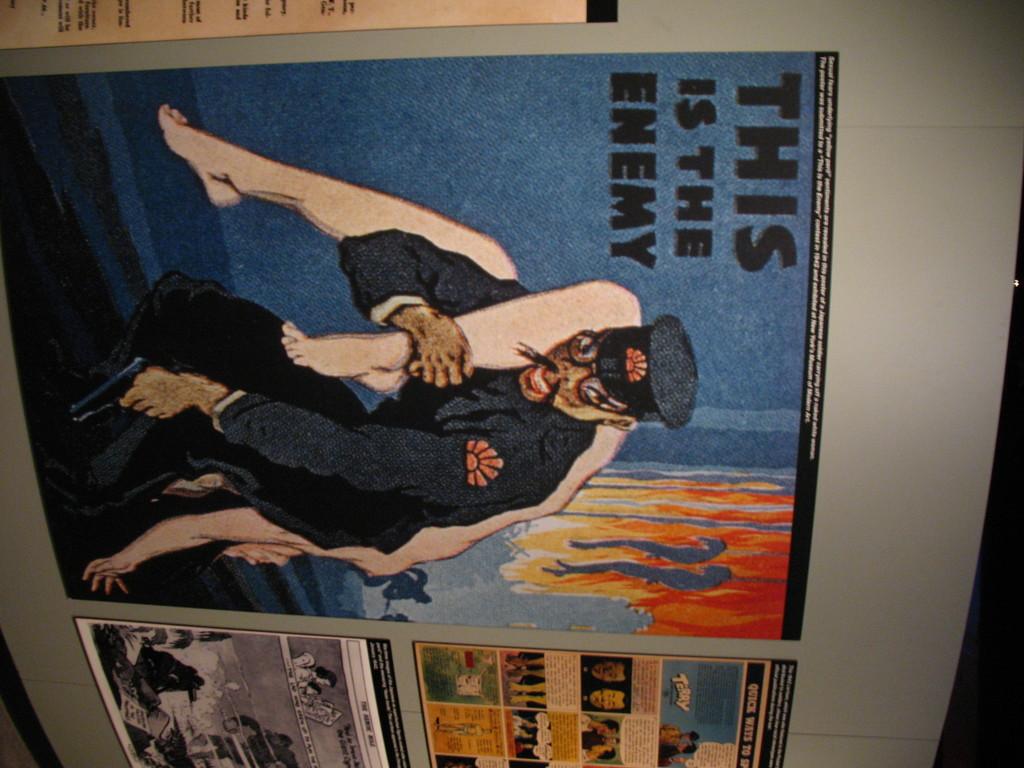What was this poster from?
Provide a short and direct response. This is the enemy. Who is the enemy?
Offer a very short reply. This. 